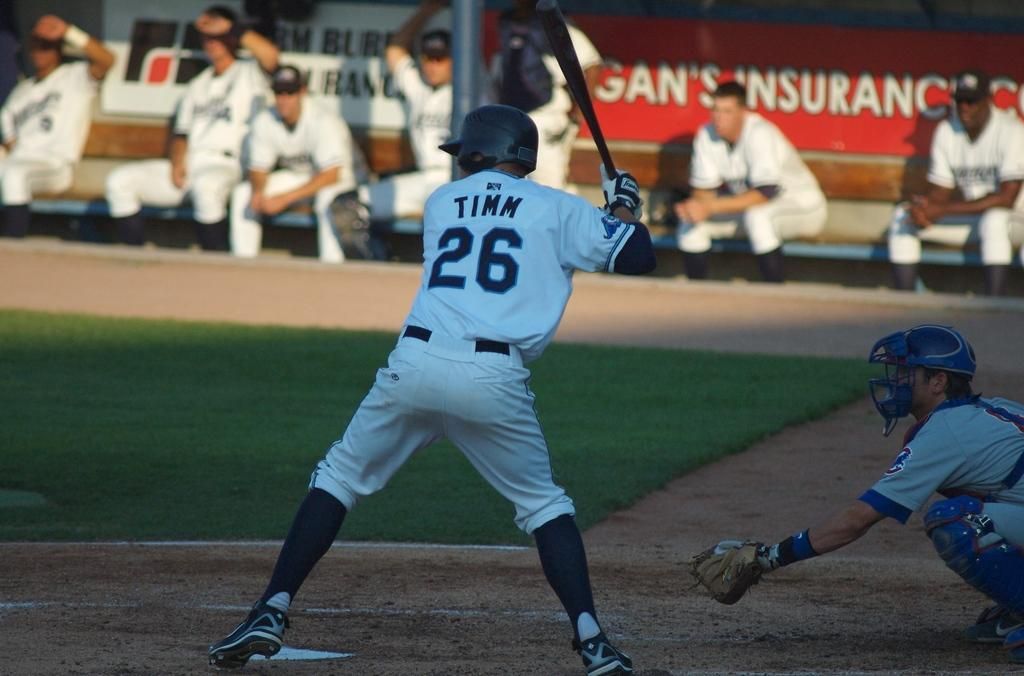<image>
Offer a succinct explanation of the picture presented. Tinn is up at bat at the baseball game. 